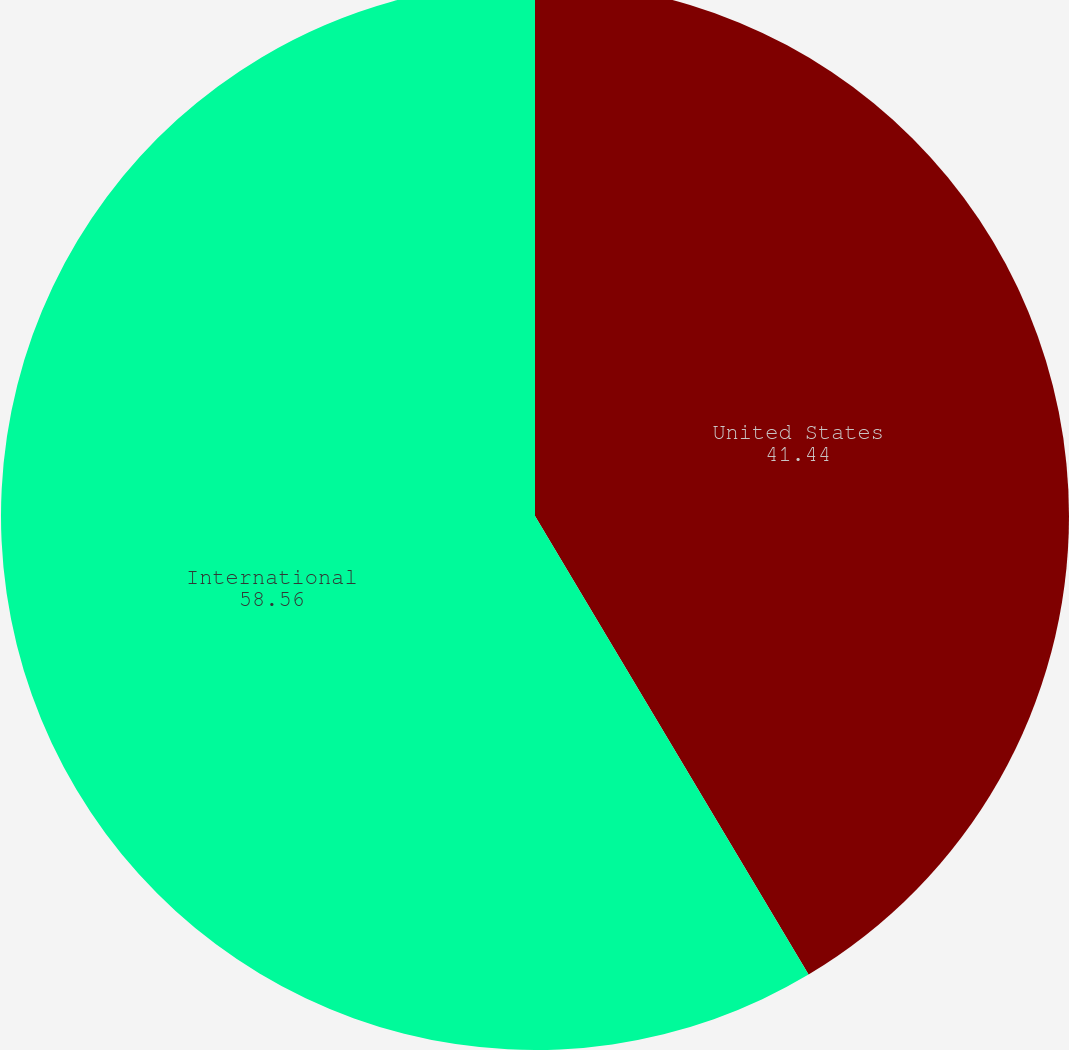Convert chart to OTSL. <chart><loc_0><loc_0><loc_500><loc_500><pie_chart><fcel>United States<fcel>International<nl><fcel>41.44%<fcel>58.56%<nl></chart> 